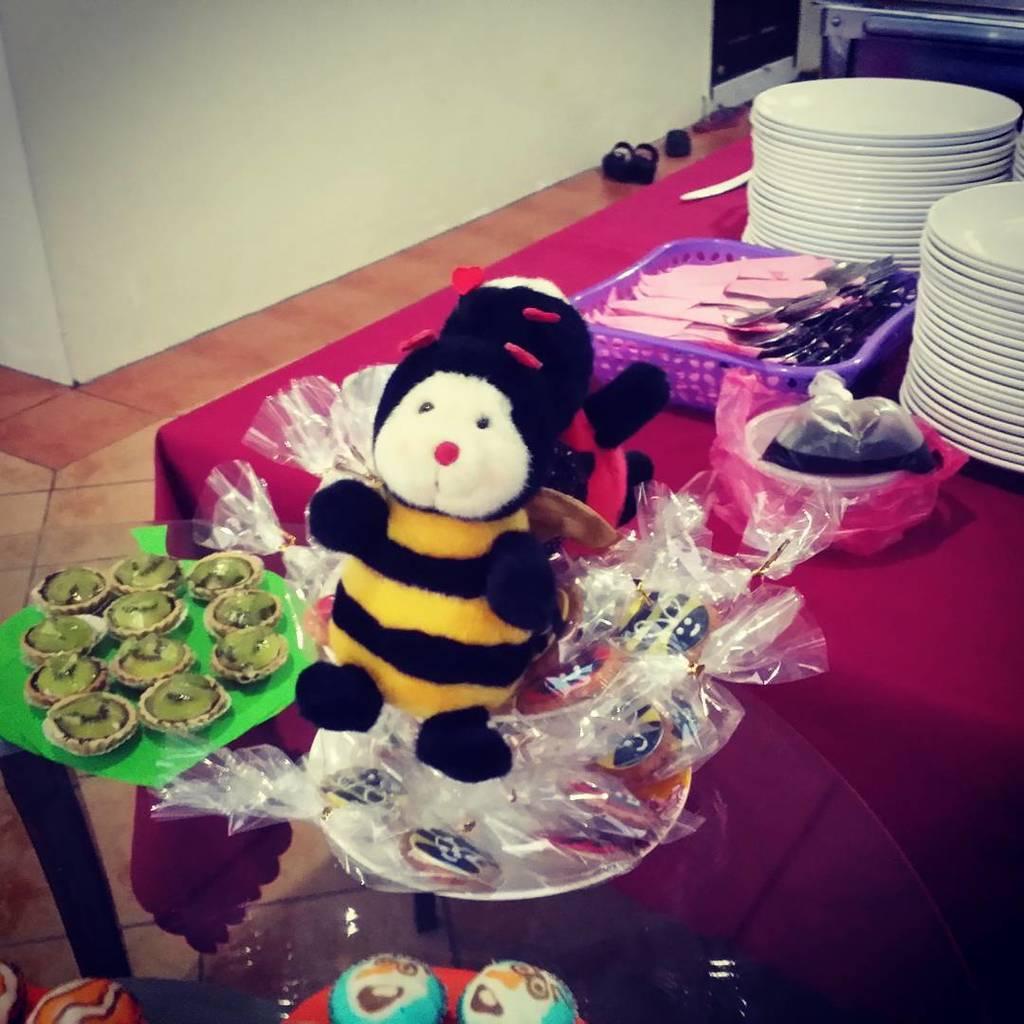Describe this image in one or two sentences. In this image we can see there is a toy in the foreground and on the right side there are many plates placed one after the other on the table. 